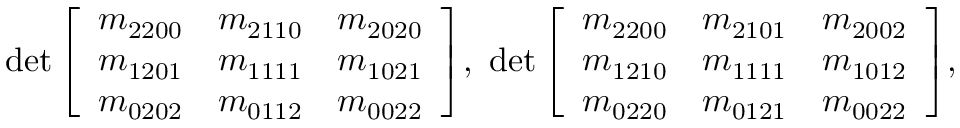<formula> <loc_0><loc_0><loc_500><loc_500>d e t \left [ \begin{array} { l l l } { m _ { 2 2 0 0 } } & { m _ { 2 1 1 0 } } & { m _ { 2 0 2 0 } } \\ { m _ { 1 2 0 1 } } & { m _ { 1 1 1 1 } } & { m _ { 1 0 2 1 } } \\ { m _ { 0 2 0 2 } } & { m _ { 0 1 1 2 } } & { m _ { 0 0 2 2 } } \end{array} \right ] \, , \, d e t \left [ \begin{array} { l l l } { m _ { 2 2 0 0 } } & { m _ { 2 1 0 1 } } & { m _ { 2 0 0 2 } } \\ { m _ { 1 2 1 0 } } & { m _ { 1 1 1 1 } } & { m _ { 1 0 1 2 } } \\ { m _ { 0 2 2 0 } } & { m _ { 0 1 2 1 } } & { m _ { 0 0 2 2 } } \end{array} \right ] \, , \,</formula> 